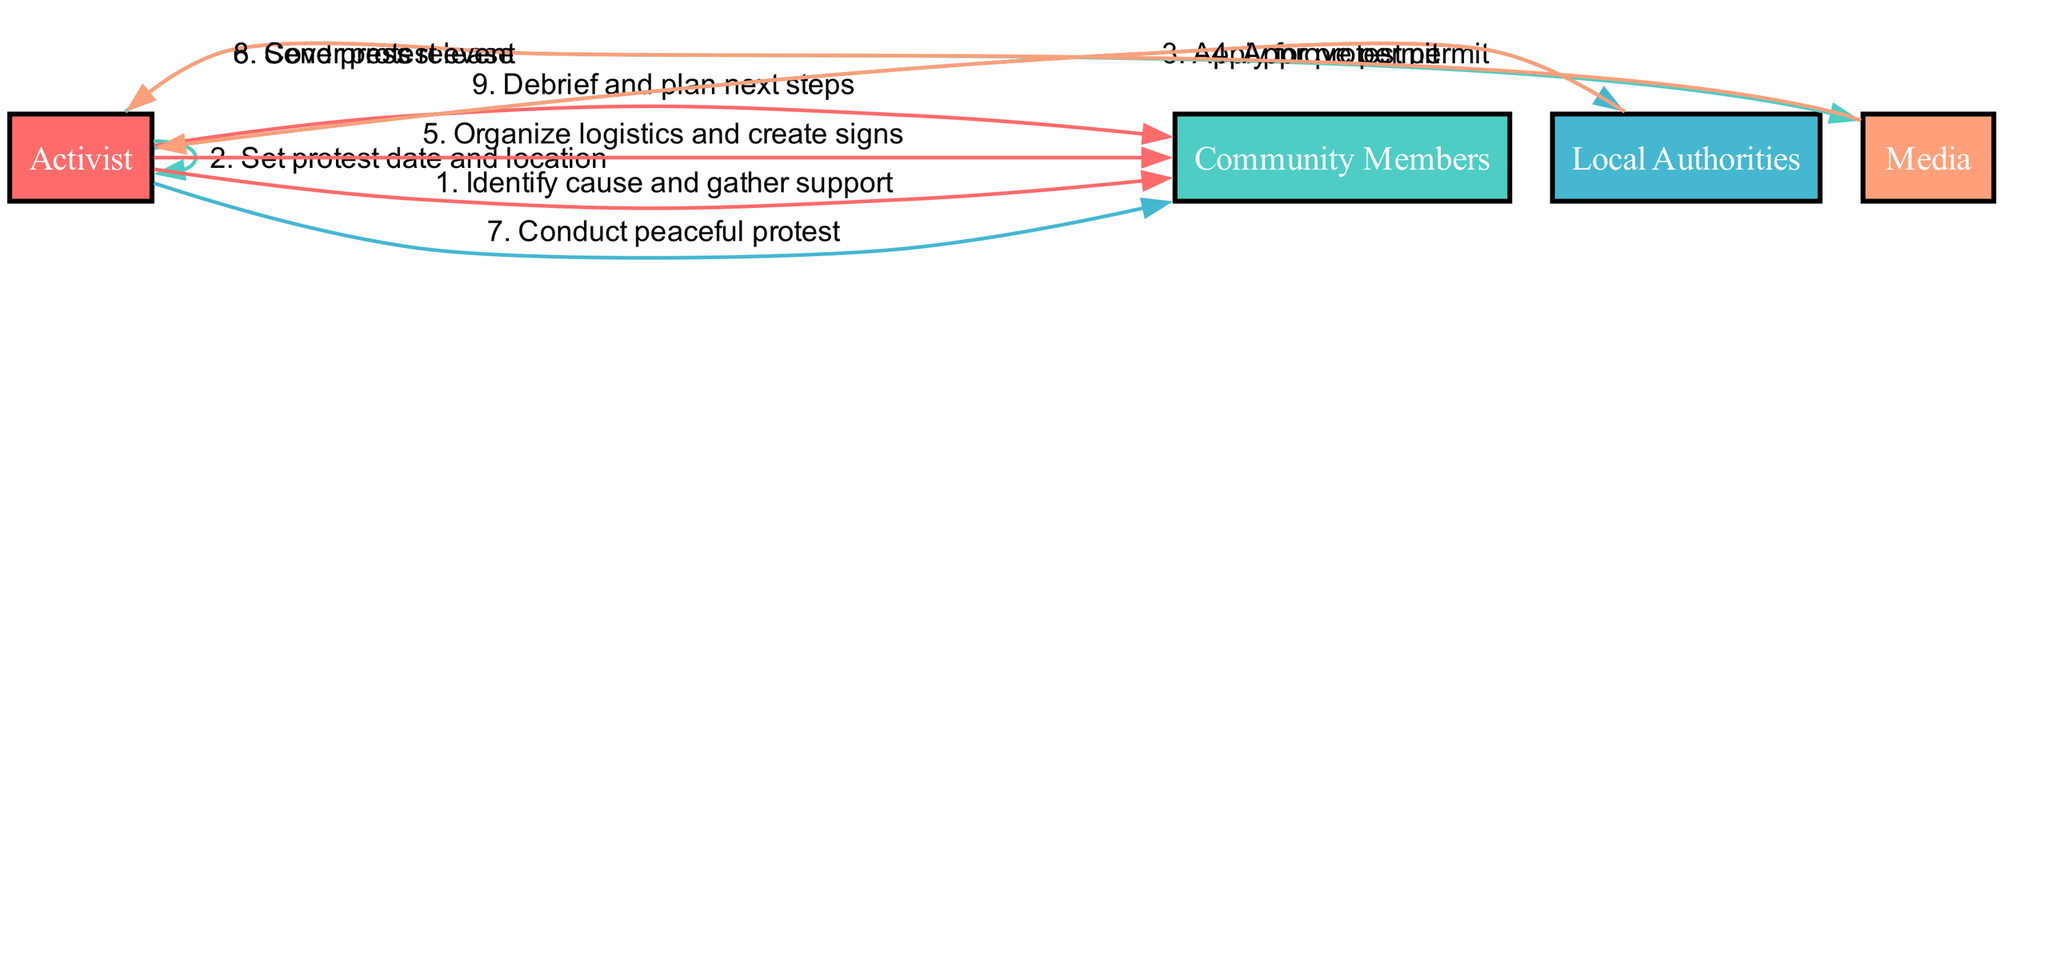What is the first action performed in the sequence? The first action is performed by the Activist who identifies the cause and gathers support from the Community Members.
Answer: Identify cause and gather support How many actors are involved in the sequence? The diagram lists four distinct actors: Activist, Community Members, Local Authorities, and Media.
Answer: 4 Which actor applies for the protest permit? The actor responsible for applying for the protest permit is the Activist, as indicated in the diagram.
Answer: Activist What action follows the approval of the permit? After the Local Authorities approve the permit, the next action is organizing logistics and creating signs, which is carried out by the Activist.
Answer: Organize logistics and create signs Which actor covers the protest event? The Media is the actor that covers the protest event, as shown in the sequence diagram.
Answer: Media What is the total number of actions in this sequence? The sequence consists of eight actions that take place from the initial planning to the post-event debriefing.
Answer: 8 Which actors are involved in the debriefing and planning of next steps? The debriefing and planning for next steps involve both the Activist and the Community Members.
Answer: Activist and Community Members What is the last action executed in the sequence? The last action executed in the sequence is the debrief and planning of next steps, indicating a reflection on the protest.
Answer: Debrief and plan next steps Which action involves sending information to the press? The action that involves sending information to the press is labeled as sending a press release, performed by the Activist.
Answer: Send press release 